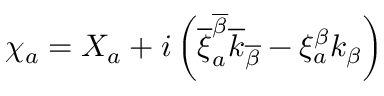<formula> <loc_0><loc_0><loc_500><loc_500>\chi _ { a } = X _ { a } + i \left ( \overline { \xi } _ { a } ^ { \overline { \beta } } \overline { k } _ { \overline { \beta } } - \xi _ { a } ^ { \beta } k _ { \beta } \right )</formula> 